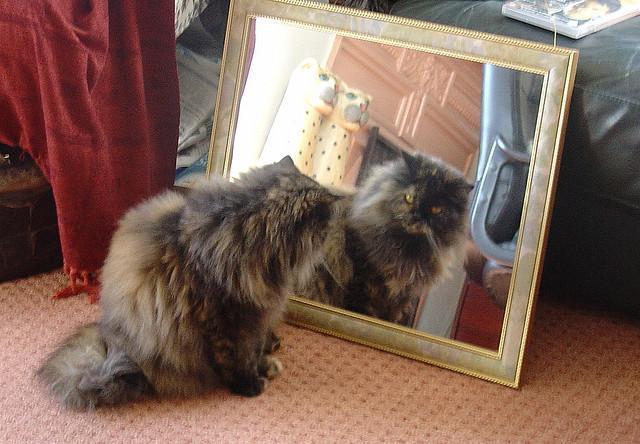How many bike on this image?
Give a very brief answer. 0. 